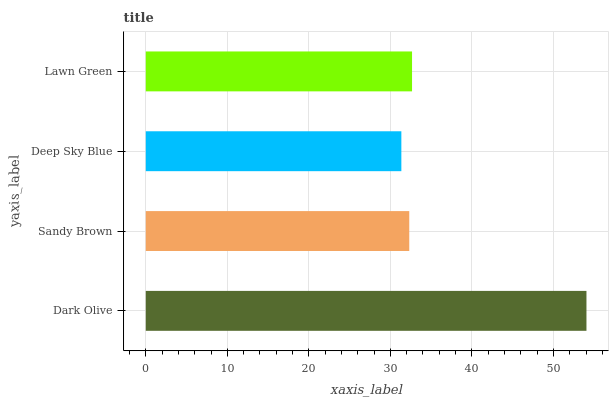Is Deep Sky Blue the minimum?
Answer yes or no. Yes. Is Dark Olive the maximum?
Answer yes or no. Yes. Is Sandy Brown the minimum?
Answer yes or no. No. Is Sandy Brown the maximum?
Answer yes or no. No. Is Dark Olive greater than Sandy Brown?
Answer yes or no. Yes. Is Sandy Brown less than Dark Olive?
Answer yes or no. Yes. Is Sandy Brown greater than Dark Olive?
Answer yes or no. No. Is Dark Olive less than Sandy Brown?
Answer yes or no. No. Is Lawn Green the high median?
Answer yes or no. Yes. Is Sandy Brown the low median?
Answer yes or no. Yes. Is Dark Olive the high median?
Answer yes or no. No. Is Lawn Green the low median?
Answer yes or no. No. 